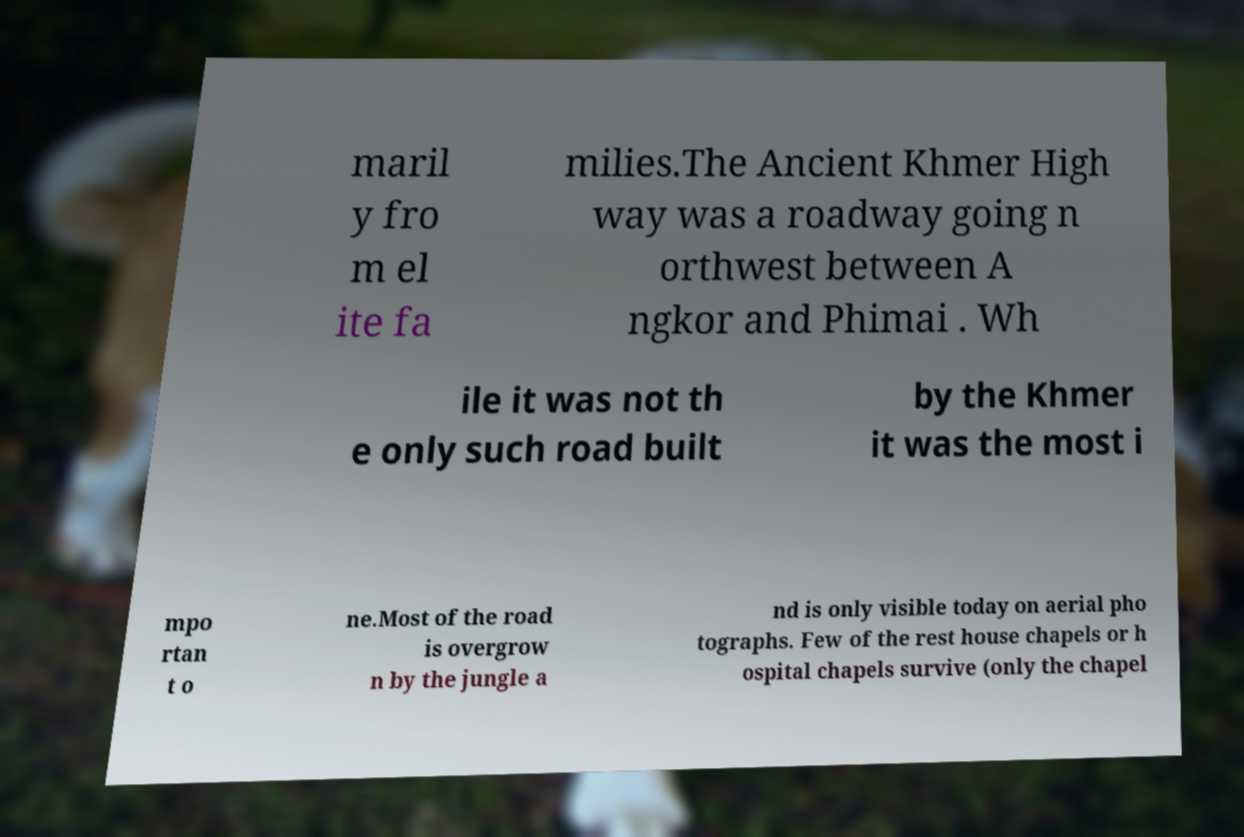Please read and relay the text visible in this image. What does it say? maril y fro m el ite fa milies.The Ancient Khmer High way was a roadway going n orthwest between A ngkor and Phimai . Wh ile it was not th e only such road built by the Khmer it was the most i mpo rtan t o ne.Most of the road is overgrow n by the jungle a nd is only visible today on aerial pho tographs. Few of the rest house chapels or h ospital chapels survive (only the chapel 